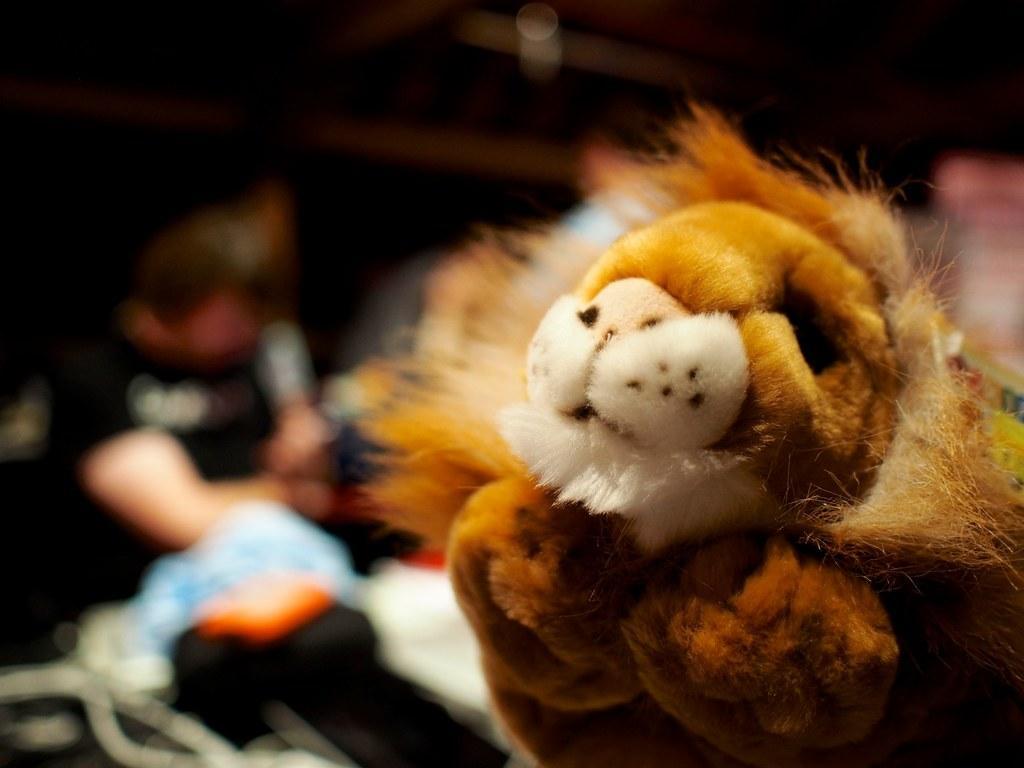Can you describe this image briefly? In this image we can see a soft toy and we can see few objects in the background. 